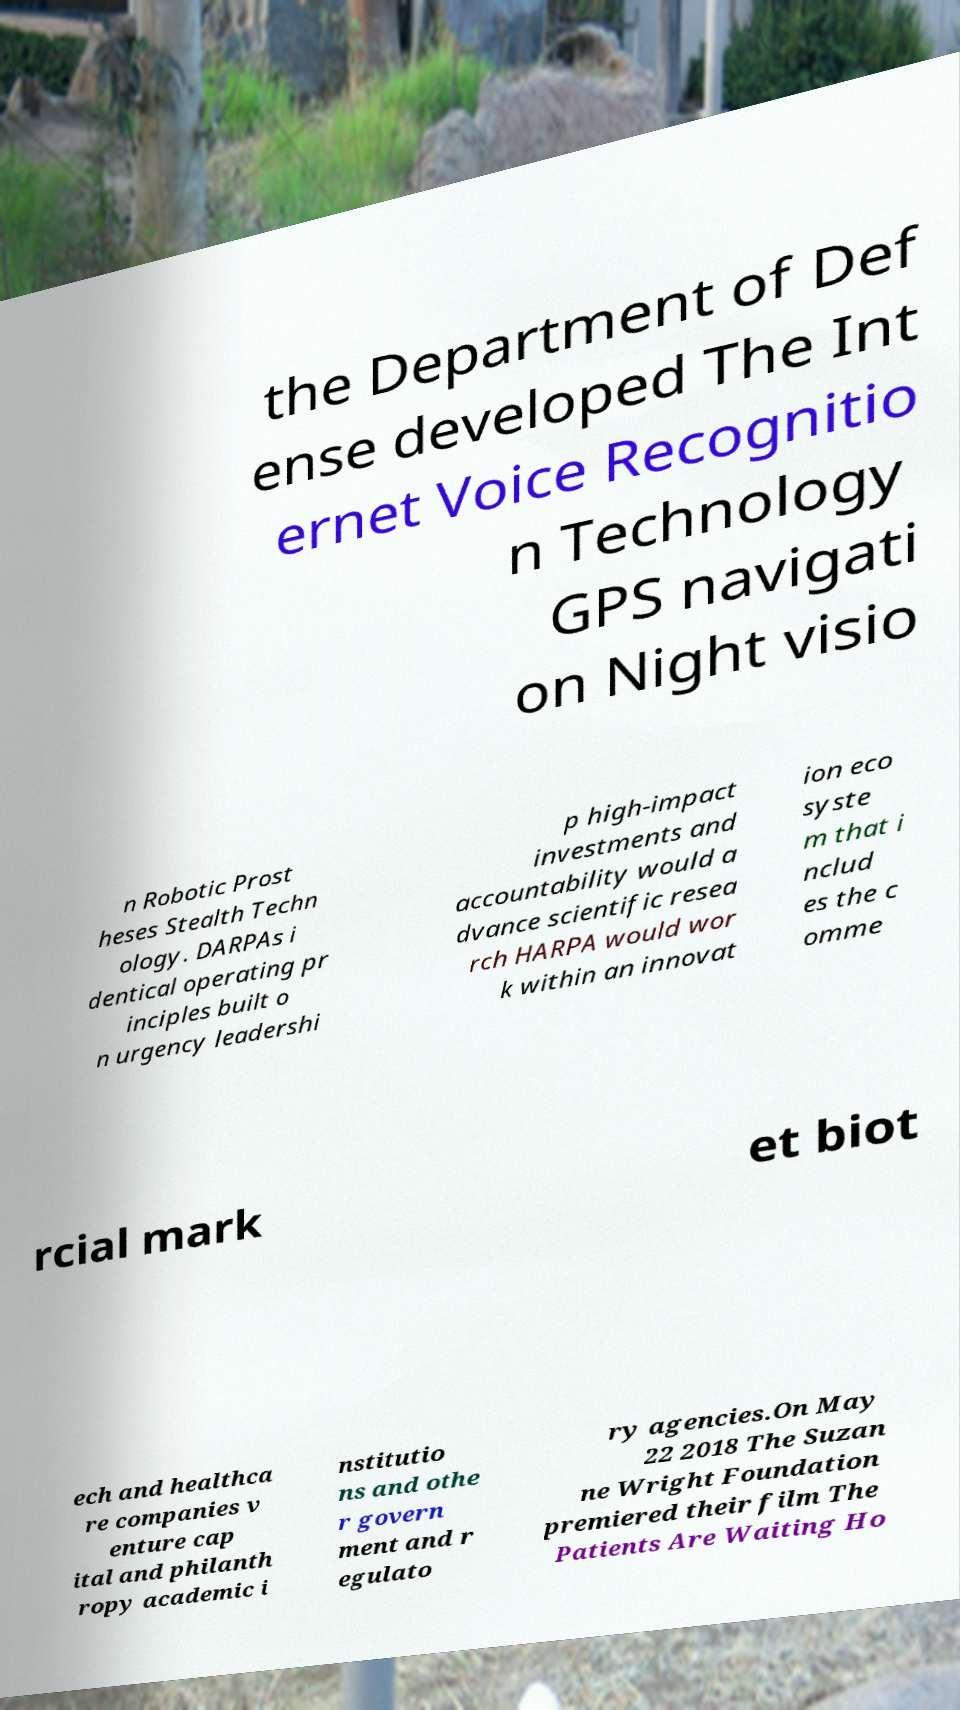Could you extract and type out the text from this image? the Department of Def ense developed The Int ernet Voice Recognitio n Technology GPS navigati on Night visio n Robotic Prost heses Stealth Techn ology. DARPAs i dentical operating pr inciples built o n urgency leadershi p high-impact investments and accountability would a dvance scientific resea rch HARPA would wor k within an innovat ion eco syste m that i nclud es the c omme rcial mark et biot ech and healthca re companies v enture cap ital and philanth ropy academic i nstitutio ns and othe r govern ment and r egulato ry agencies.On May 22 2018 The Suzan ne Wright Foundation premiered their film The Patients Are Waiting Ho 